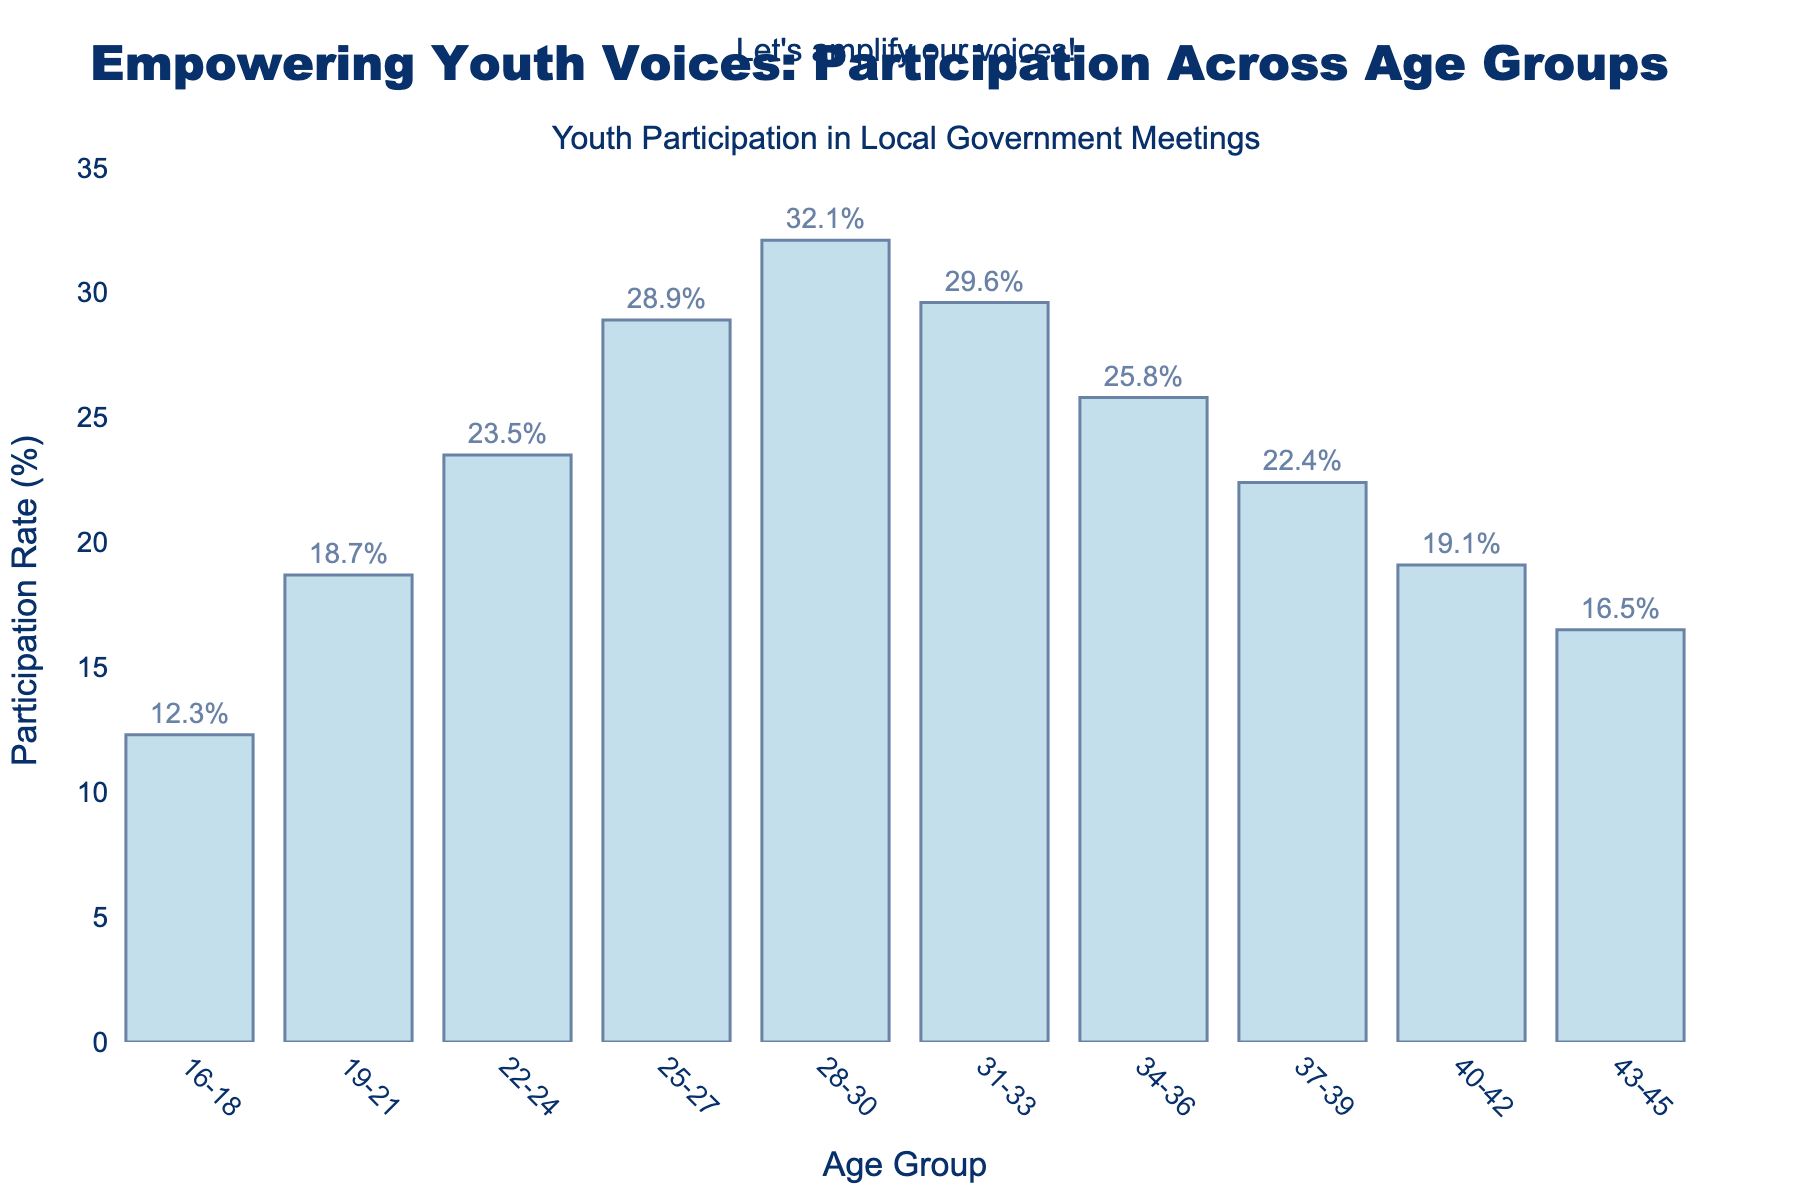What's the age group with the lowest participation rate? Look at the bars to find the one with the lowest height, which corresponds to the age group with the lowest value on the y-axis. The 16-18 age group has the lowest participation rate of 12.3%.
Answer: 16-18 What is the difference in participation rates between the youngest and oldest age groups? Find the participation rates of the 16-18 age group (12.3%) and the 43-45 age group (16.5%), then subtract the smaller rate from the larger rate. The difference is 16.5% - 12.3% = 4.2%.
Answer: 4.2% Which age group has the highest participation rate, and what is it? Look at the bar with the highest value on the y-axis and note the age group it represents. The 28-30 age group has the highest participation rate of 32.1%.
Answer: 28-30, 32.1% How many age groups have a participation rate above 20%? Count the number of bars that are taller than the 20% mark on the y-axis. The age groups 22-24, 25-27, and 28-30 have rates above 20%, so the total is 3.
Answer: 3 Compare the participation rates of the 22-24 and 31-33 age groups. Which group has a higher rate, and by how much? Look at the heights of the bars for the 22-24 and 31-33 age groups. The 22-24 age group has a rate of 23.5%, and the 31-33 age group has a rate of 29.6%. The difference is 29.6% - 23.5% = 6.1%. The 31-33 age group is higher by 6.1%.
Answer: 31-33, 6.1% What is the average participation rate for the age groups between 22-30? Calculate the sum of the participation rates for the 22-24, 25-27, and 28-30 age groups and then divide by the number of groups. (23.5% + 28.9% + 32.1%) / 3 = 84.5% / 3 = 28.17%.
Answer: 28.17% Which age groups have declining participation rates after the peak at 28-30? Identify the bars after the 28-30 age group and compare their heights, noting those which decrease. The bars after the peak and their participation rates are: 31-33 (29.6%), 34-36 (25.8%), 37-39 (22.4%), 40-42 (19.1%), and 43-45 (16.5%). All these groups show a decline.
Answer: 31-33, 34-36, 37-39, 40-42, 43-45 What is the total participation rate for the 19-21 and 40-42 age groups combined? Add the participation rates of the 19-21 age group (18.7%) and the 40-42 age group (19.1%). The total is 18.7% + 19.1% = 37.8%.
Answer: 37.8% By how much does the participation rate change from the 19-21 age group to the 25-27 age group? Subtract the participation rate of the 19-21 age group (18.7%) from the 25-27 age group (28.9%). The change is 28.9% - 18.7% = 10.2%.
Answer: 10.2% How does the participation rate for the age group 37-39 compare to the average participation rate for all groups? First, find the average participation rate for all groups: sum the rates (12.3% + 18.7% + 23.5% + 28.9% + 32.1% + 29.6% + 25.8% + 22.4% + 19.1% + 16.5%) which equals 229.9%, then divide by the number of age groups, 229.9% / 10 = 22.99%. Compare it to 37-39's rate of 22.4%. The 37-39 group is lower than the average by 22.99% - 22.4% = 0.59%.
Answer: 0.59% lower 